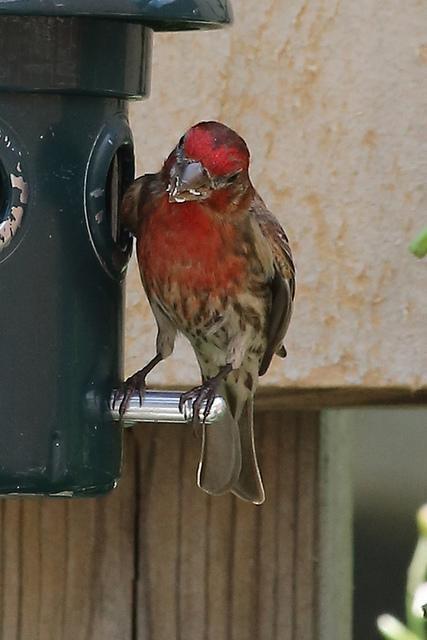How many polar bears are there?
Give a very brief answer. 0. 